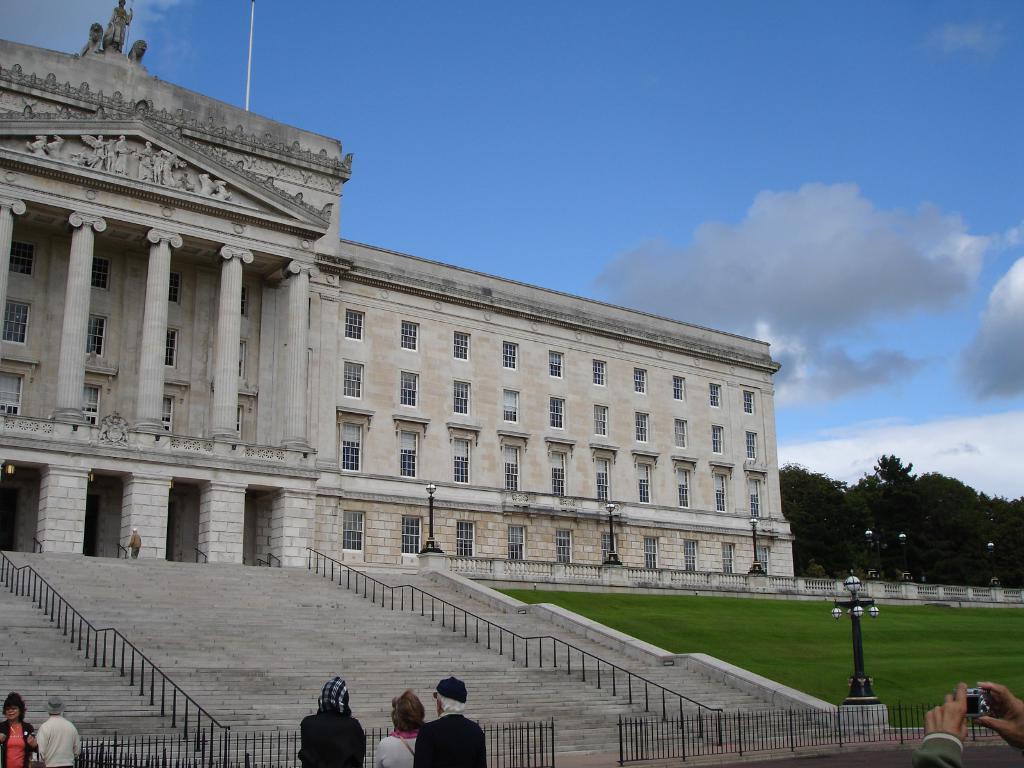Can you describe this image briefly? In this image I can see a building, steps and a fence. Here I can see people and the grass. In the background I can see trees and the sky. 